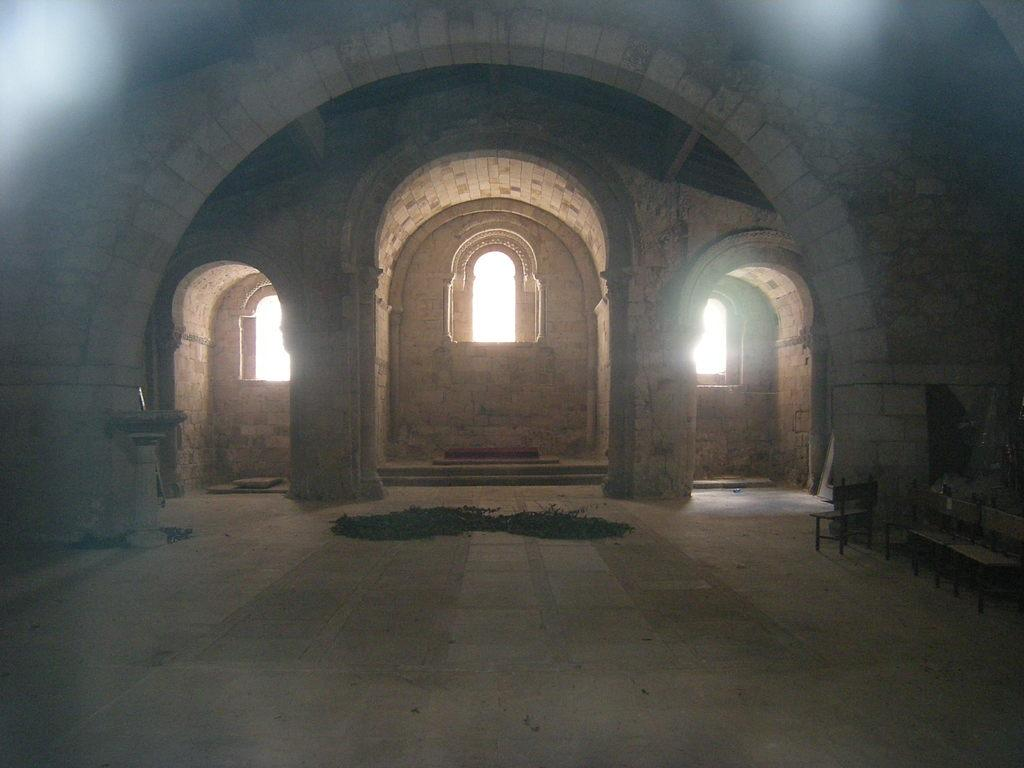What type of structure is shown in the image? The image shows an inside view of a fort. What architectural features can be seen at the front of the fort? There are three arches in the front of the fort. What type of openings are present in the arches? There are small windows in the arches. What size of matches can be found in the image? There are no matches present in the image. What type of cover is used to protect the fort in the image? The image shows an inside view of the fort, so there is no cover visible. 